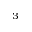<formula> <loc_0><loc_0><loc_500><loc_500>_ { 3 }</formula> 